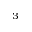<formula> <loc_0><loc_0><loc_500><loc_500>_ { 3 }</formula> 